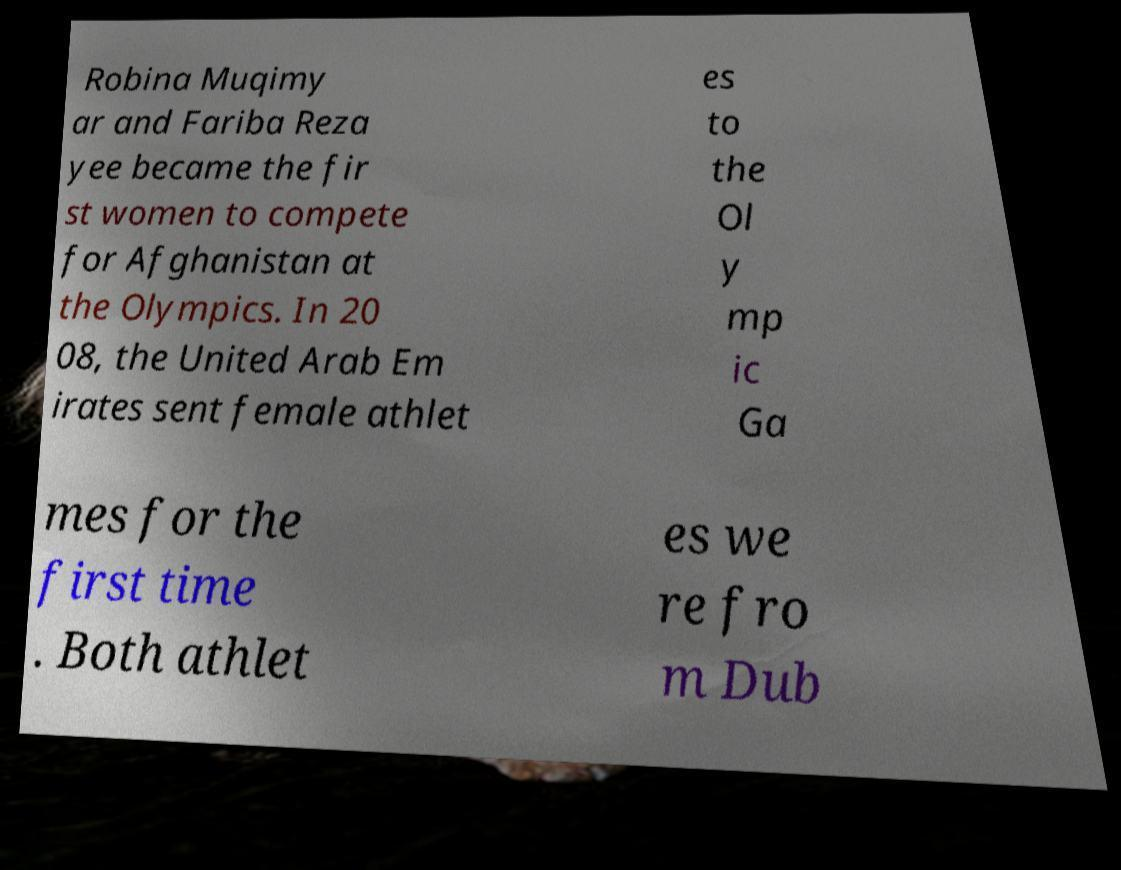Can you accurately transcribe the text from the provided image for me? Robina Muqimy ar and Fariba Reza yee became the fir st women to compete for Afghanistan at the Olympics. In 20 08, the United Arab Em irates sent female athlet es to the Ol y mp ic Ga mes for the first time . Both athlet es we re fro m Dub 